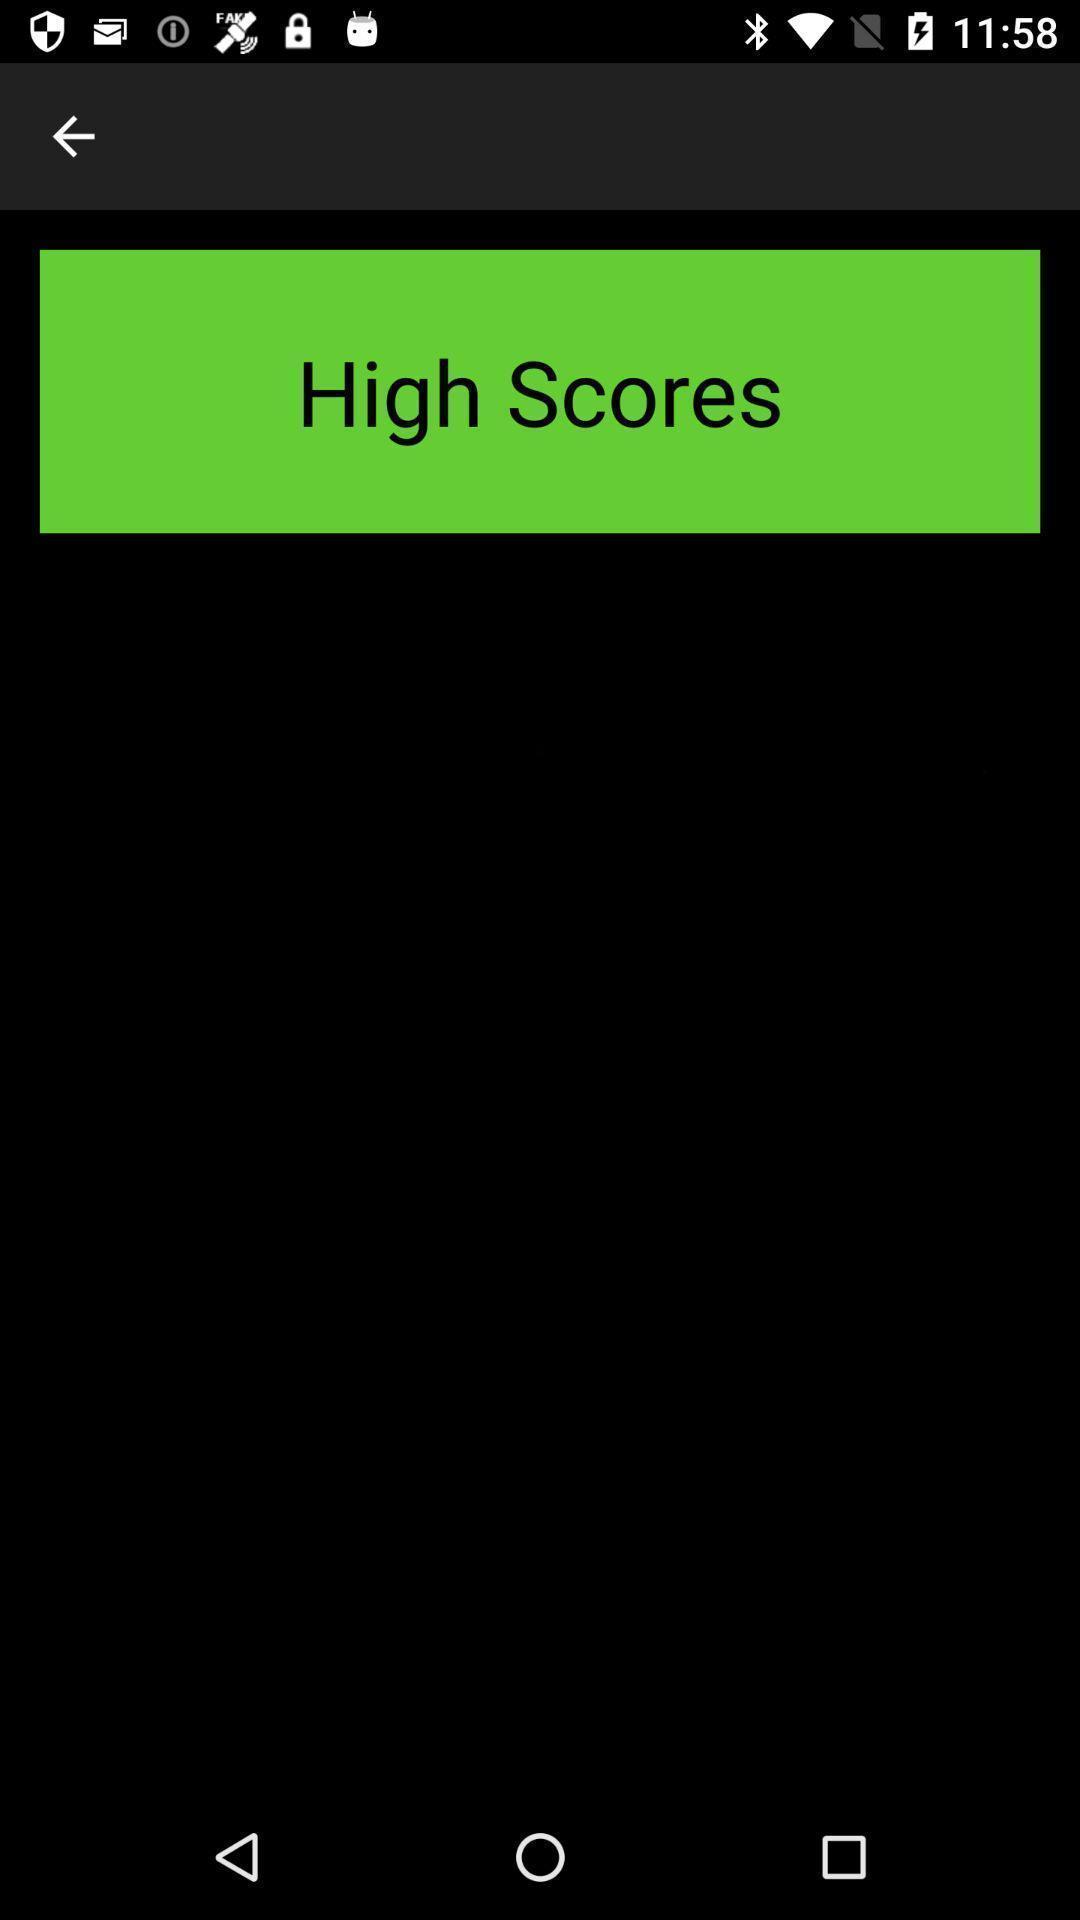Explain the elements present in this screenshot. Screen page displaying an information. 